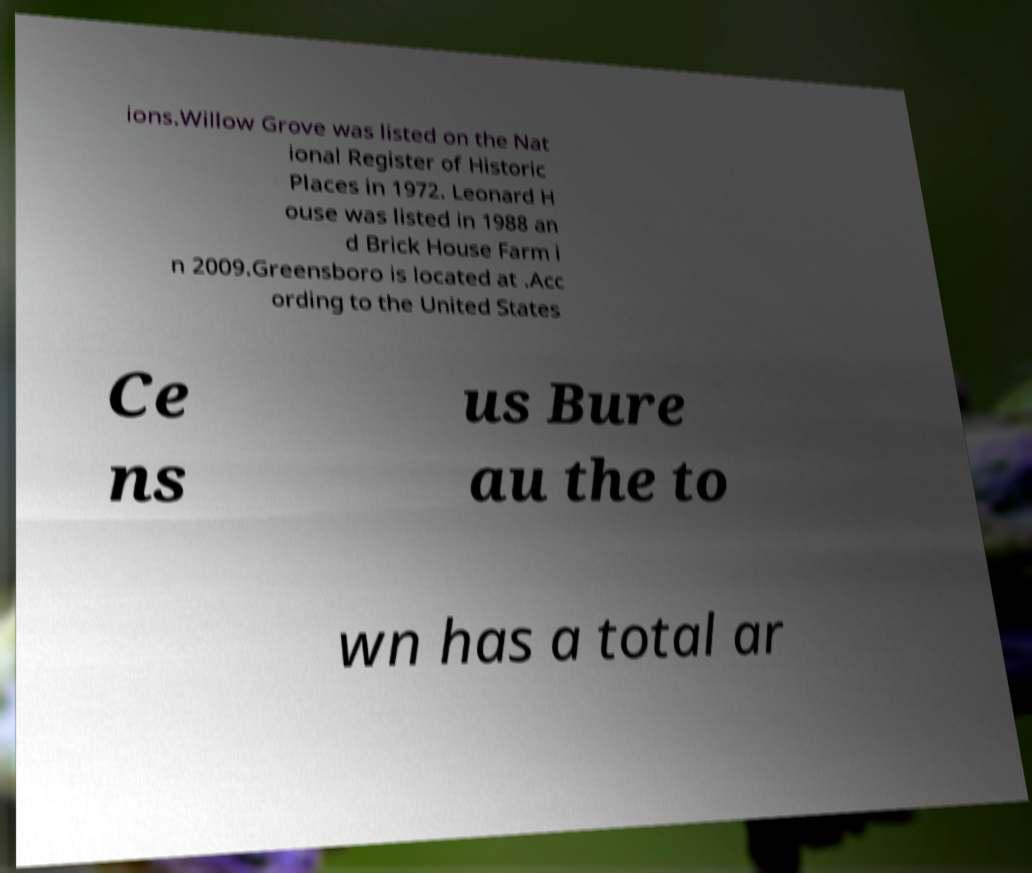Could you assist in decoding the text presented in this image and type it out clearly? ions.Willow Grove was listed on the Nat ional Register of Historic Places in 1972. Leonard H ouse was listed in 1988 an d Brick House Farm i n 2009.Greensboro is located at .Acc ording to the United States Ce ns us Bure au the to wn has a total ar 